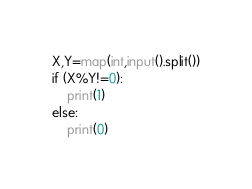<code> <loc_0><loc_0><loc_500><loc_500><_Python_>X,Y=map(int,input().split())
if (X%Y!=0):
	print(1)
else:
	print(0)</code> 